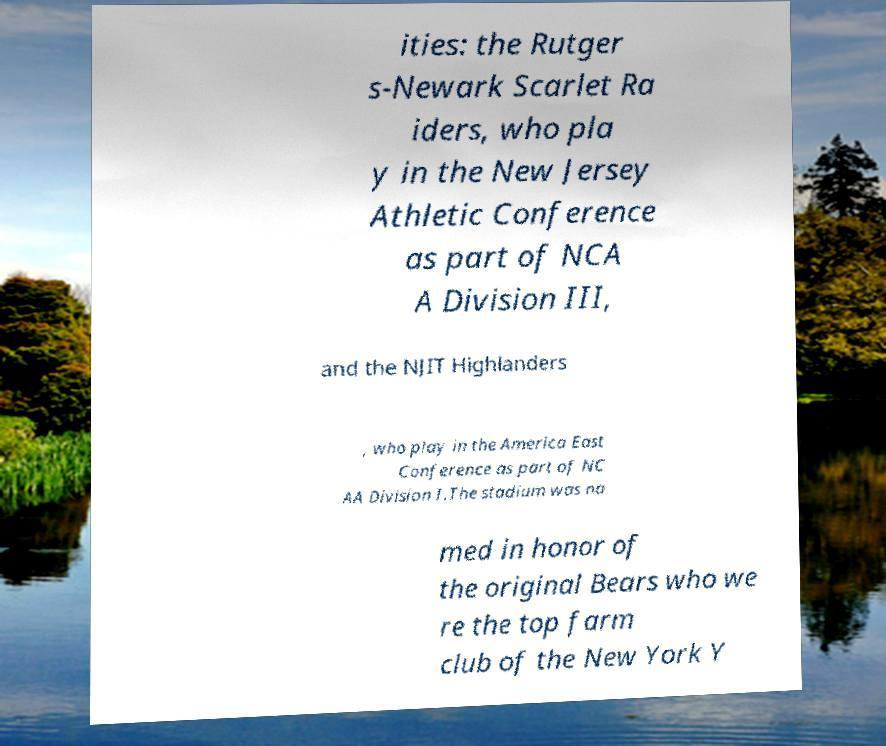Please read and relay the text visible in this image. What does it say? ities: the Rutger s-Newark Scarlet Ra iders, who pla y in the New Jersey Athletic Conference as part of NCA A Division III, and the NJIT Highlanders , who play in the America East Conference as part of NC AA Division I.The stadium was na med in honor of the original Bears who we re the top farm club of the New York Y 